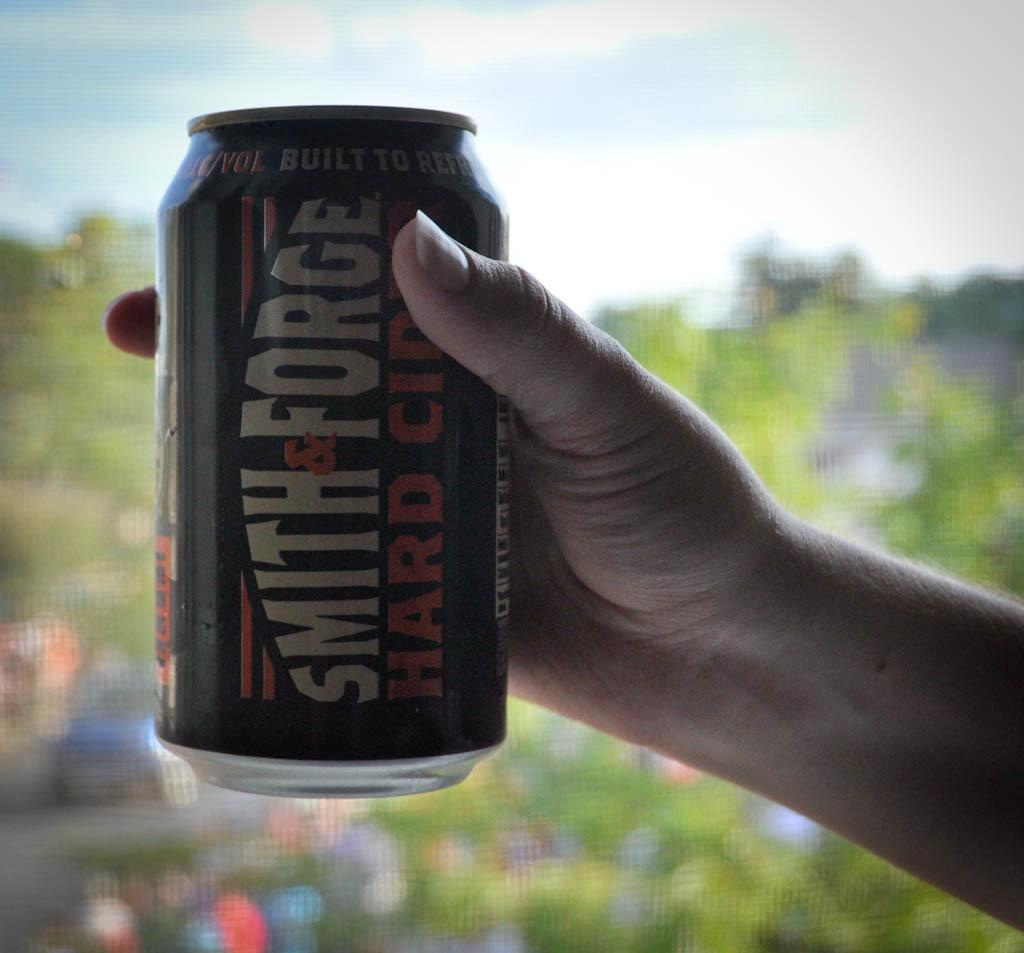Who or what is present in the image? There is a person in the image. What is the person holding? The person is holding a tin. What type of natural environment can be seen in the image? There are trees in the image. What else can be seen in the image besides the person and trees? There are objects in the image. What is visible in the sky in the image? There are clouds in the sky. What type of mint is being used to flavor the liquid in the image? There is no mint or liquid present in the image. 